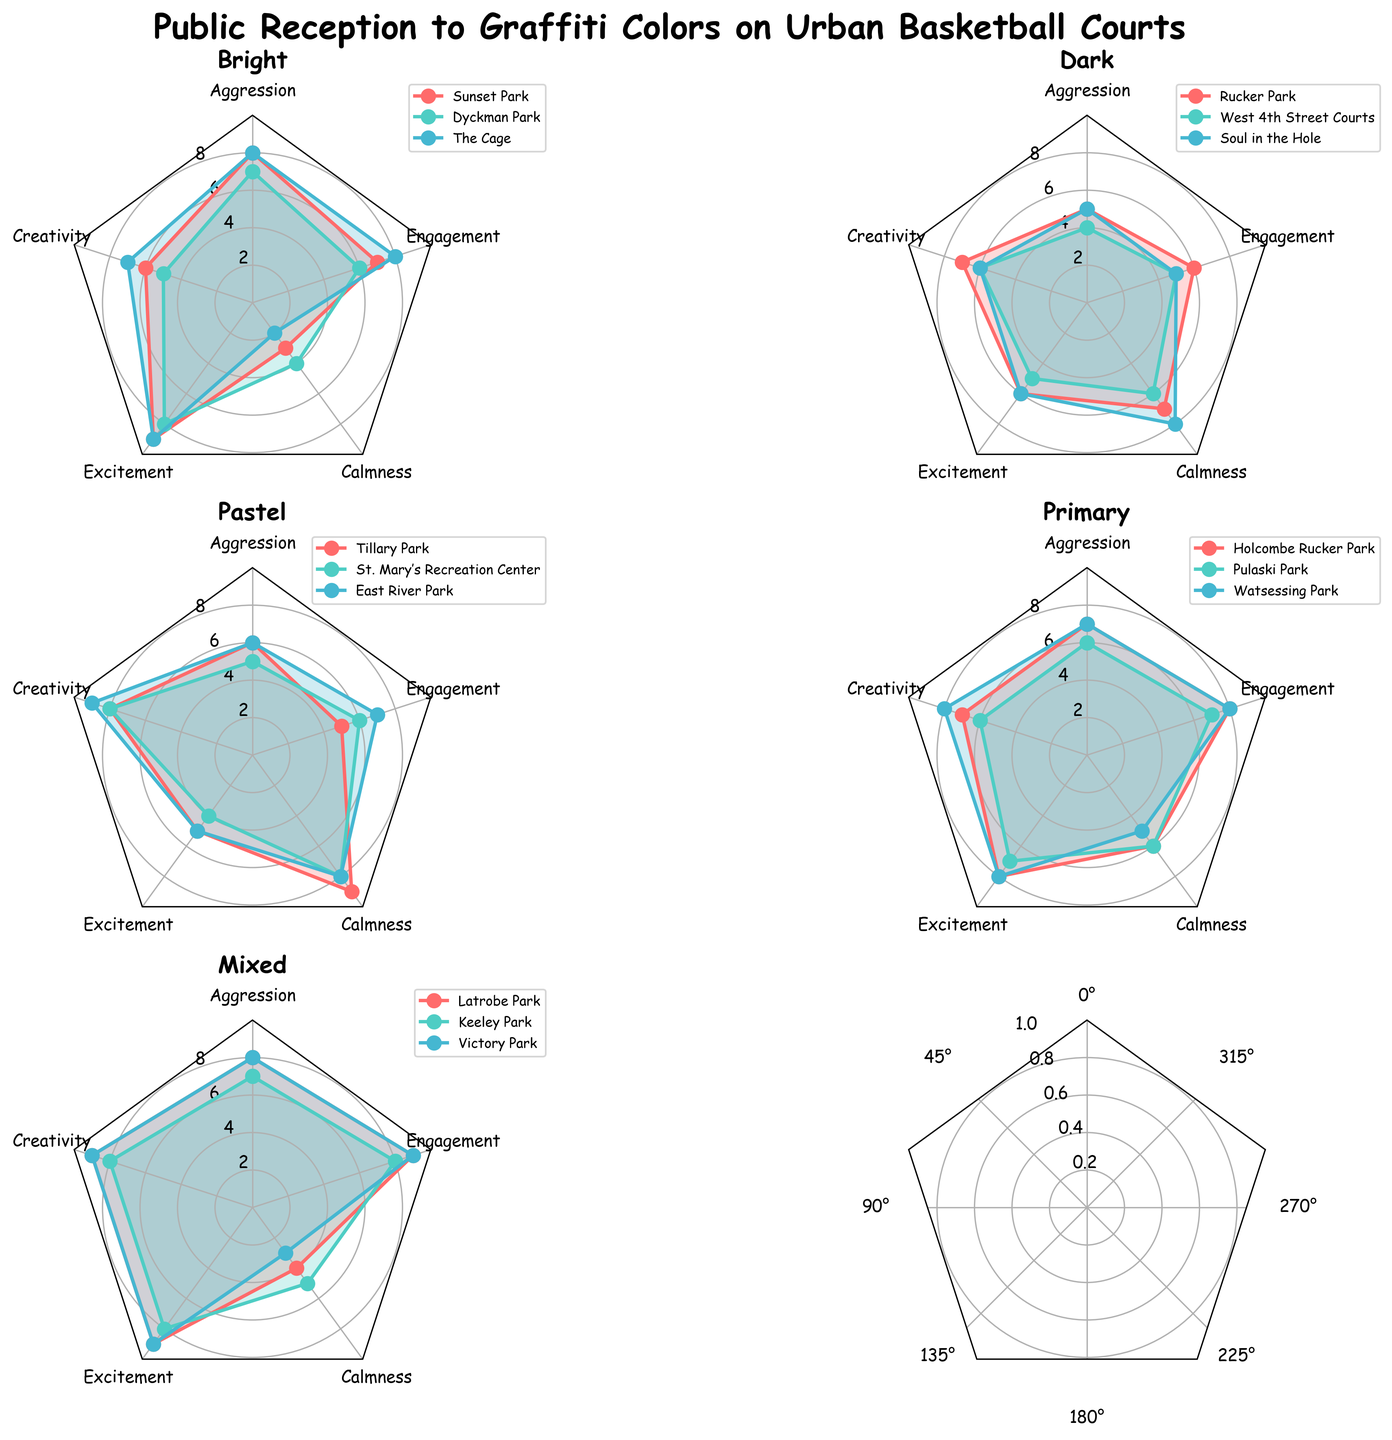What's the title of the figure? The title of the figure is displayed at the top in bold, which is "Public Reception to Graffiti Colors on Urban Basketball Courts."
Answer: Public Reception to Graffiti Colors on Urban Basketball Courts Which color has the highest average creativity score across all locations? To find the highest average creativity score, look at the 'Creativity' axis on each radar plot and compare the averages for different colors. Bright has 6, 5, and 7 (average: 6), Dark has 7, 6, and 6 (average: 6.33), Pastel has 8, 8, and 9 (average: 8.33), Primary has 7, 6, and 8 (average: 7), and Mixed has 9, 8, and 9 (average: 8.67). Mixed has the highest average.
Answer: Mixed Which location with 'Mixed' colors shows the highest levels of Engagement? Look at the 'Engagement' axis in the 'Mixed' colors radar plots. Compare the scores: Latrobe Park (9), Keeley Park (8), Victory Park (9). Both Latrobe Park and Victory Park have the highest engagement scores.
Answer: Latrobe Park and Victory Park How does the 'Calmness' score for 'Dark' colors at Soul in the Hole compare to 'Primary' colors at Pulaski Park? Look at the radar plots for 'Dark' and 'Primary' colors, and specifically at 'Calmness' for Soul in the Hole and Pulaski Park. The 'Calmness' score for Soul in the Hole is 8, and for Pulaski Park it is 6. Soul in the Hole has a higher 'Calmness' score than Pulaski Park.
Answer: Soul in the Hole has a higher score Which color has the lowest 'Aggression' score on average, and what is that score? Calculate the 'Aggression' score average for each color. Bright has 8, 7, 8 (average: 7.67), Dark has 5, 4, 5 (average: 4.67), Pastel has 6, 5, 6 (average: 5.67), Primary has 7, 6, 7 (average: 6.67), and Mixed has 8, 7, 8 (average: 7.67). Dark has the lowest average score of 4.67.
Answer: Dark, 4.67 Which location associated with 'Bright' colors shows the highest 'Excitement' score and what is that score? Compare the 'Excitement' scores for all locations with 'Bright' colors. Sunset Park (9), Dyckman Park (8), The Cage (9). Both Sunset Park and The Cage have the highest 'Excitement' score of 9.
Answer: Sunset Park and The Cage, 9 What is the average 'Calmness' level for locations with 'Pastel' colors? Identify the 'Calmness' scores in 'Pastel' color radar plots: Tillary Park (9), St. Mary's Recreation Center (8), East River Park (8). Sum these values (9 + 8 + 8 = 25) and divide by the number of locations (3) to get the average: 25/3 = 8.33.
Answer: 8.33 Which location exhibits the highest levels of both 'Creativity' and 'Engagement' in the 'Primary' color category? Look at the plots for 'Primary' colors and compare the 'Creativity' and 'Engagement' scores. Holcombe Rucker Park (7, 8), Pulaski Park (6, 7), Watsessing Park (8, 8). Watsessing Park has the highest combined levels for 'Creativity' and 'Engagement'.
Answer: Watsessing Park Is there any color that has a perfect score (10) in any category across all locations? Examine the radar plots for each color and see if any location has a score of 10 in any category. None of the radar plots for the colors display a perfect score of 10 in any category.
Answer: No 